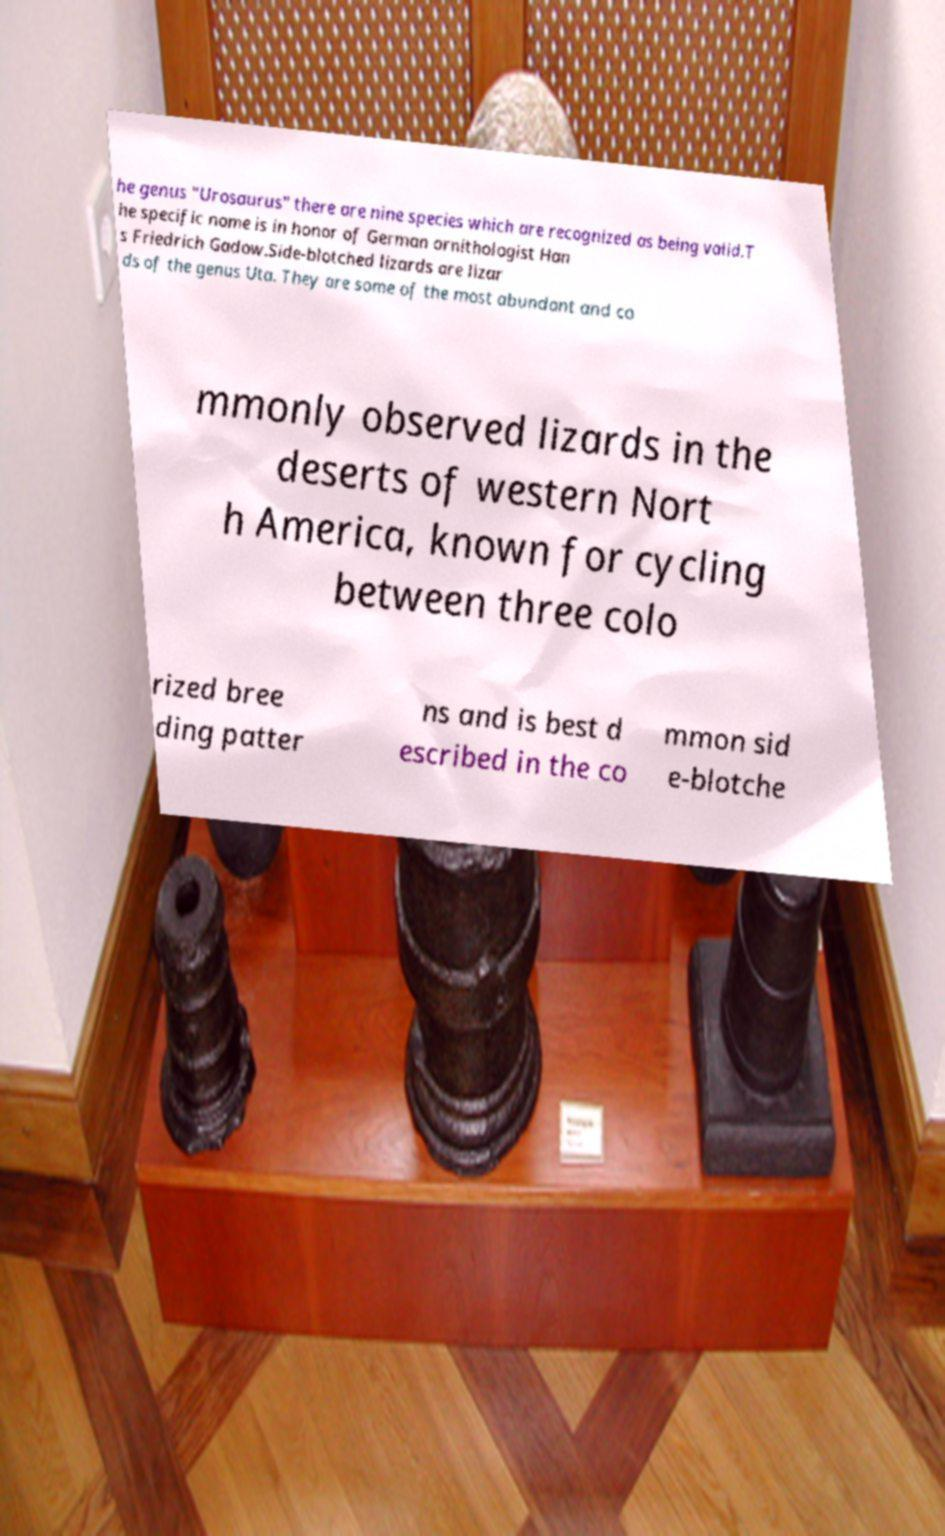I need the written content from this picture converted into text. Can you do that? he genus "Urosaurus" there are nine species which are recognized as being valid.T he specific name is in honor of German ornithologist Han s Friedrich Gadow.Side-blotched lizards are lizar ds of the genus Uta. They are some of the most abundant and co mmonly observed lizards in the deserts of western Nort h America, known for cycling between three colo rized bree ding patter ns and is best d escribed in the co mmon sid e-blotche 